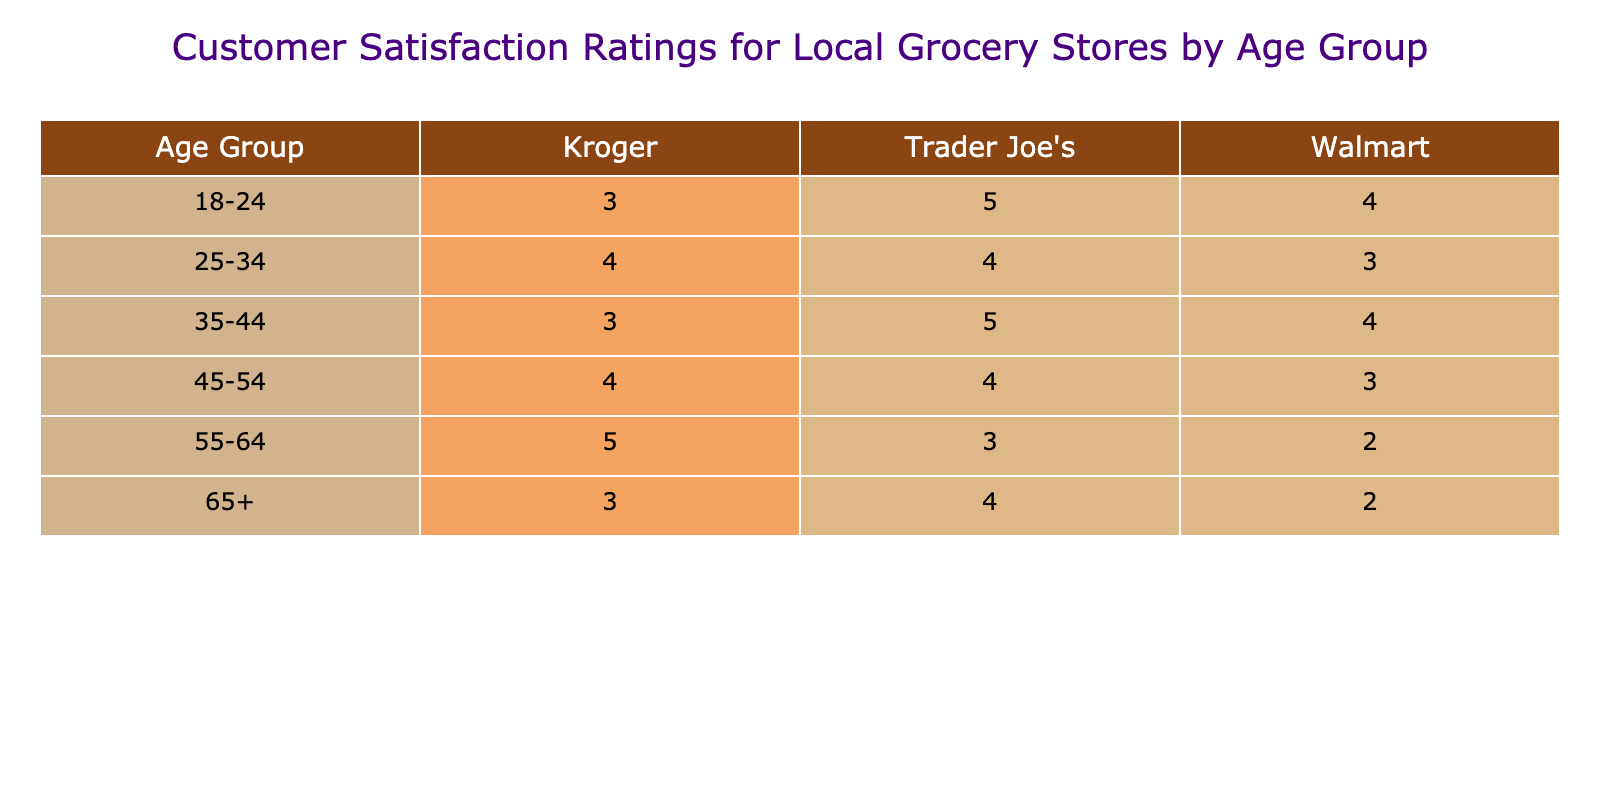What is the satisfaction rating of Trader Joe's for customers aged 65 and over? Looking at the table, the satisfaction rating for Trader Joe's under the age group 65+ is 4.
Answer: 4 Which store received the highest satisfaction rating from the 55-64 age group? The highest rating in the 55-64 age group is for Kroger, which received a satisfaction rating of 5.
Answer: Kroger What is the average satisfaction rating for Walmart across all age groups? To find the average for Walmart, add the ratings: (4 + 3 + 4 + 3 + 2 + 2) = 18. There are 6 ratings, so the average is 18/6 = 3.0.
Answer: 3.0 Is Trader Joe's rated higher than Kroger for the 25-34 age group? For the 25-34 age group, Trader Joe's has a satisfaction rating of 4, and Kroger also has a rating of 4, thus they are equal.
Answer: No Which age group had the lowest satisfaction rating for Walmart? The table shows that the 55-64 and 65+ age groups both have the lowest satisfaction rating for Walmart, where both had a rating of 2.
Answer: 55-64 and 65+ What is the total satisfaction rating for Kroger across all age groups? The ratings for Kroger are: 3 (18-24) + 4 (25-34) + 3 (35-44) + 4 (45-54) + 5 (55-64) + 3 (65+) = 22.
Answer: 22 For which age group did Trader Joe's have the highest satisfaction rating? The highest rating for Trader Joe's is 5, which occurs for the 18-24 and 35-44 age groups.
Answer: 18-24 and 35-44 Did any store receive a satisfaction rating of 5 from the 45-54 age group? Evaluating the table shows that no store received a satisfaction rating of 5 for the 45-54 age group; both Trader Joe's and Kroger had ratings of 4.
Answer: No 